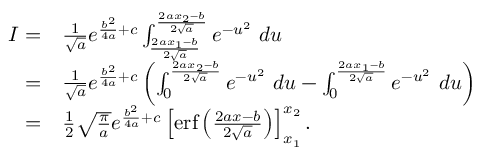<formula> <loc_0><loc_0><loc_500><loc_500>\begin{array} { r l } { I = } & { \frac { 1 } { \sqrt { a } } e ^ { \frac { b ^ { 2 } } { 4 a } + c } \int _ { \frac { 2 a x _ { 1 } - b } { 2 \sqrt { a } } } ^ { \frac { 2 a x _ { 2 } - b } { 2 \sqrt { a } } } e ^ { - u ^ { 2 } } \ d u } \\ { = } & { \frac { 1 } { \sqrt { a } } e ^ { \frac { b ^ { 2 } } { 4 a } + c } \left ( \int _ { 0 } ^ { \frac { 2 a x _ { 2 } - b } { 2 \sqrt { a } } } e ^ { - u ^ { 2 } } \ d u - \int _ { 0 } ^ { \frac { 2 a x _ { 1 } - b } { 2 \sqrt { a } } } e ^ { - u ^ { 2 } } \ d u \right ) } \\ { = } & { \frac { 1 } { 2 } \sqrt { \frac { \pi } { a } } e ^ { \frac { b ^ { 2 } } { 4 a } + c } \left [ e r f \left ( { \frac { 2 a x - b } { 2 \sqrt { a } } } \right ) \right ] _ { x _ { 1 } } ^ { x _ { 2 } } . } \end{array}</formula> 